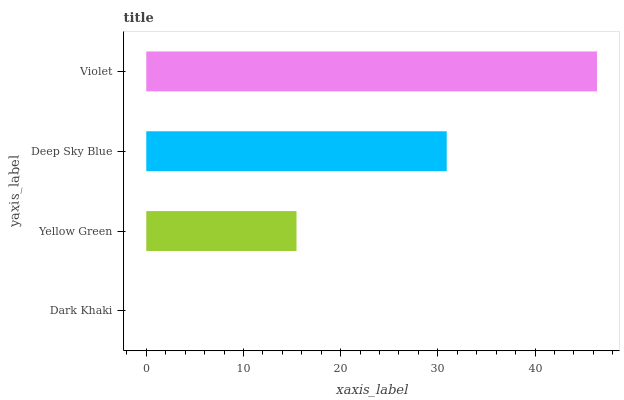Is Dark Khaki the minimum?
Answer yes or no. Yes. Is Violet the maximum?
Answer yes or no. Yes. Is Yellow Green the minimum?
Answer yes or no. No. Is Yellow Green the maximum?
Answer yes or no. No. Is Yellow Green greater than Dark Khaki?
Answer yes or no. Yes. Is Dark Khaki less than Yellow Green?
Answer yes or no. Yes. Is Dark Khaki greater than Yellow Green?
Answer yes or no. No. Is Yellow Green less than Dark Khaki?
Answer yes or no. No. Is Deep Sky Blue the high median?
Answer yes or no. Yes. Is Yellow Green the low median?
Answer yes or no. Yes. Is Yellow Green the high median?
Answer yes or no. No. Is Deep Sky Blue the low median?
Answer yes or no. No. 